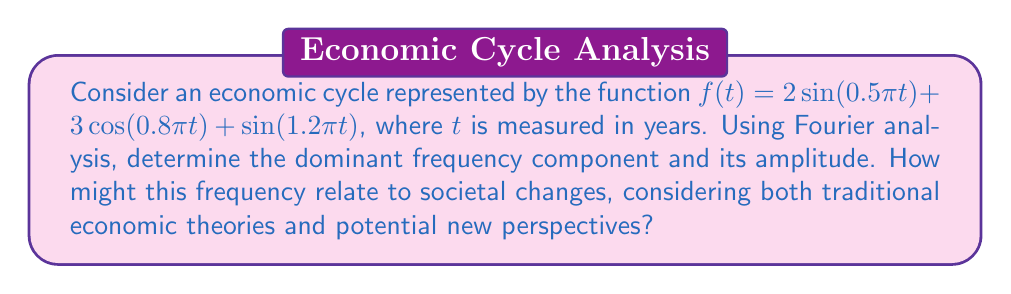Provide a solution to this math problem. To solve this problem, we'll follow these steps:

1) First, we need to identify the frequency components in the given function. The function is already expressed as a sum of sinusoids, so we can read the frequencies directly:

   $f(t) = 2\sin(0.5\pi t) + 3\cos(0.8\pi t) + \sin(1.2\pi t)$

   The frequencies are:
   $\omega_1 = 0.5\pi$
   $\omega_2 = 0.8\pi$
   $\omega_3 = 1.2\pi$

2) To convert these to cycles per year, we divide by $2\pi$:

   $f_1 = 0.25$ cycles/year (4-year period)
   $f_2 = 0.4$ cycles/year (2.5-year period)
   $f_3 = 0.6$ cycles/year (1.67-year period)

3) The amplitudes of these components are:

   $A_1 = 2$
   $A_2 = 3$
   $A_3 = 1$

4) The dominant frequency component is the one with the largest amplitude, which is $f_2 = 0.4$ cycles/year with an amplitude of 3.

5) Interpreting this result:
   The dominant cycle has a period of 2.5 years, which could be related to the inventory cycle or the Kitchin cycle in traditional economic theory. This cycle is often associated with changes in business inventories and slight adjustments in GDP.

   From a conservative sociologist's perspective, this might be seen as evidence of the regularity and predictability of economic systems, reinforcing the idea of stable social structures.

   However, as a graduate student introducing new ideas, you might consider:
   - How this relatively short cycle interacts with longer-term societal changes
   - Whether the dominance of this cycle has changed over time, possibly due to technological advancements or globalization
   - How this cycle might affect different socioeconomic groups differently, potentially leading to social tensions or changes

   These considerations could lead to new research questions about the relationship between economic cycles and social change, bridging traditional economic theory with modern sociological perspectives.
Answer: The dominant frequency component is 0.4 cycles per year (2.5-year period) with an amplitude of 3. 